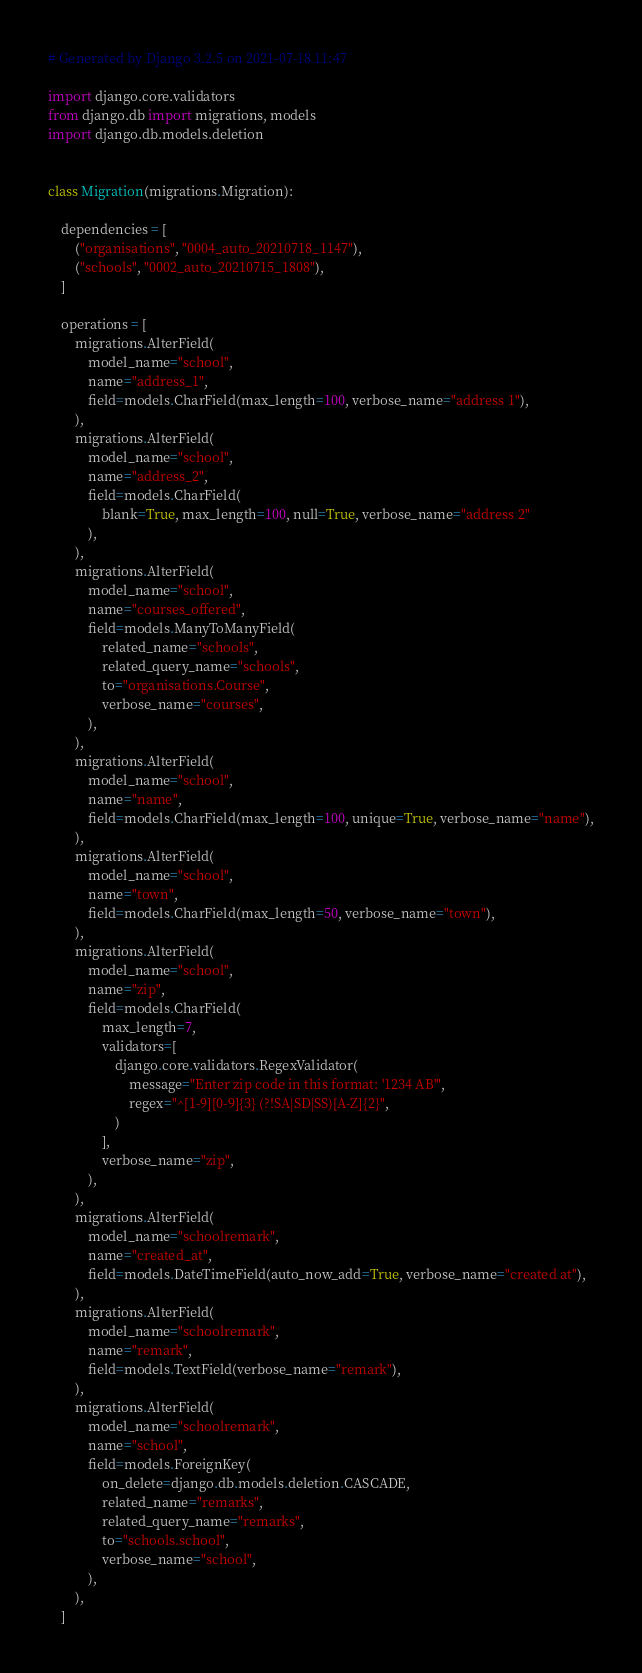<code> <loc_0><loc_0><loc_500><loc_500><_Python_># Generated by Django 3.2.5 on 2021-07-18 11:47

import django.core.validators
from django.db import migrations, models
import django.db.models.deletion


class Migration(migrations.Migration):

    dependencies = [
        ("organisations", "0004_auto_20210718_1147"),
        ("schools", "0002_auto_20210715_1808"),
    ]

    operations = [
        migrations.AlterField(
            model_name="school",
            name="address_1",
            field=models.CharField(max_length=100, verbose_name="address 1"),
        ),
        migrations.AlterField(
            model_name="school",
            name="address_2",
            field=models.CharField(
                blank=True, max_length=100, null=True, verbose_name="address 2"
            ),
        ),
        migrations.AlterField(
            model_name="school",
            name="courses_offered",
            field=models.ManyToManyField(
                related_name="schools",
                related_query_name="schools",
                to="organisations.Course",
                verbose_name="courses",
            ),
        ),
        migrations.AlterField(
            model_name="school",
            name="name",
            field=models.CharField(max_length=100, unique=True, verbose_name="name"),
        ),
        migrations.AlterField(
            model_name="school",
            name="town",
            field=models.CharField(max_length=50, verbose_name="town"),
        ),
        migrations.AlterField(
            model_name="school",
            name="zip",
            field=models.CharField(
                max_length=7,
                validators=[
                    django.core.validators.RegexValidator(
                        message="Enter zip code in this format: '1234 AB'",
                        regex="^[1-9][0-9]{3} (?!SA|SD|SS)[A-Z]{2}",
                    )
                ],
                verbose_name="zip",
            ),
        ),
        migrations.AlterField(
            model_name="schoolremark",
            name="created_at",
            field=models.DateTimeField(auto_now_add=True, verbose_name="created at"),
        ),
        migrations.AlterField(
            model_name="schoolremark",
            name="remark",
            field=models.TextField(verbose_name="remark"),
        ),
        migrations.AlterField(
            model_name="schoolremark",
            name="school",
            field=models.ForeignKey(
                on_delete=django.db.models.deletion.CASCADE,
                related_name="remarks",
                related_query_name="remarks",
                to="schools.school",
                verbose_name="school",
            ),
        ),
    ]
</code> 